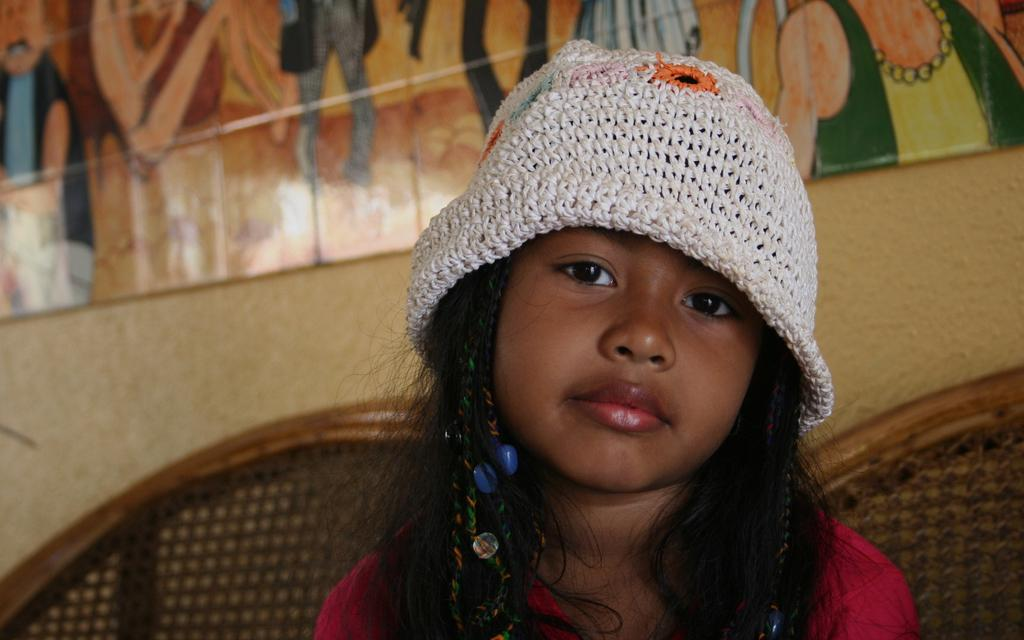Who is the main subject in the image? There is a small girl in the image. Where is the girl located in the image? The girl is sitting in the foreground area. What can be seen in the background of the image? There is a painting in the background of the image. What type of pest can be seen crawling on the girl's shoulder in the image? There is no pest visible on the girl's shoulder in the image. 